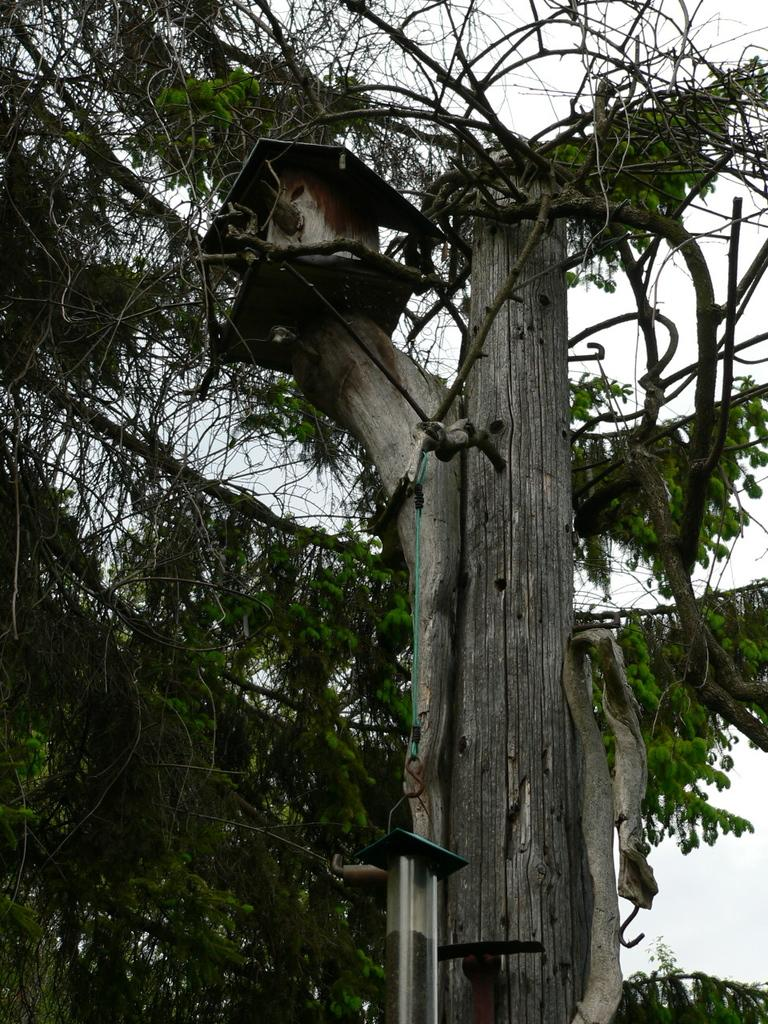What type of vegetation can be seen in the image? There are leaves and branches in the image. What structure is attached to a tree trunk in the image? There is a birdhouse on a tree trunk in the image. What is present to provide food for birds in the image? There is a bird feeder in the image. What can be seen in the background of the image? The sky is visible in the background of the image. What type of sea creature can be seen swimming in the image? There is no sea or sea creature present in the image; it features leaves, branches, a birdhouse, and a bird feeder. What is the texture of the bird's finger in the image? There is no bird or bird's finger present in the image. 